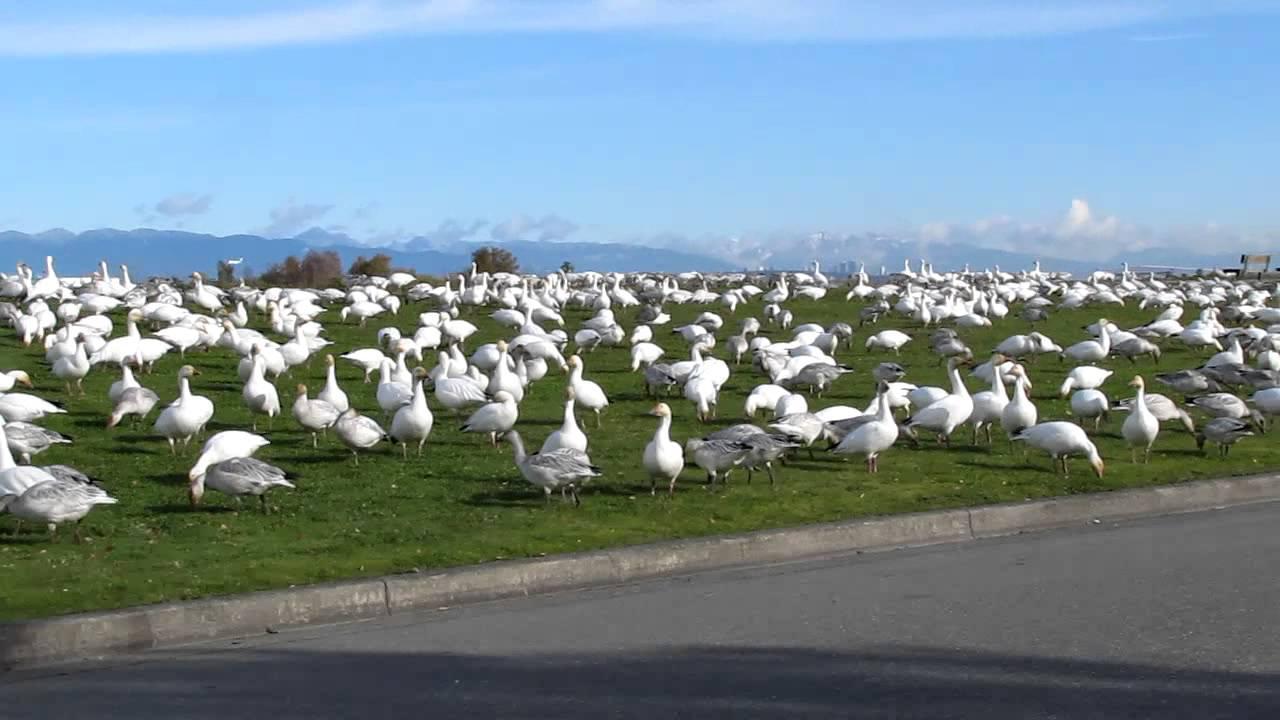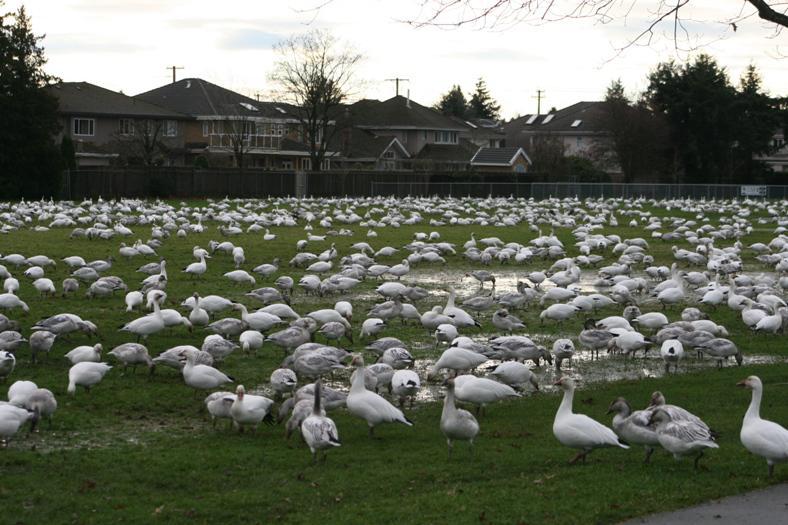The first image is the image on the left, the second image is the image on the right. Examine the images to the left and right. Is the description "Some of the birds in the image on the left are flying in the air." accurate? Answer yes or no. No. The first image is the image on the left, the second image is the image on the right. Assess this claim about the two images: "All birds are flying in the sky above a green field in one image.". Correct or not? Answer yes or no. No. 